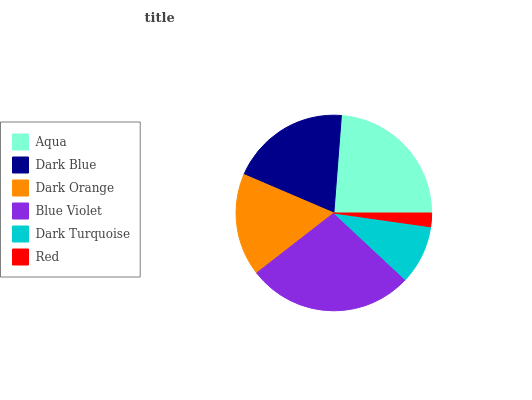Is Red the minimum?
Answer yes or no. Yes. Is Blue Violet the maximum?
Answer yes or no. Yes. Is Dark Blue the minimum?
Answer yes or no. No. Is Dark Blue the maximum?
Answer yes or no. No. Is Aqua greater than Dark Blue?
Answer yes or no. Yes. Is Dark Blue less than Aqua?
Answer yes or no. Yes. Is Dark Blue greater than Aqua?
Answer yes or no. No. Is Aqua less than Dark Blue?
Answer yes or no. No. Is Dark Blue the high median?
Answer yes or no. Yes. Is Dark Orange the low median?
Answer yes or no. Yes. Is Red the high median?
Answer yes or no. No. Is Dark Turquoise the low median?
Answer yes or no. No. 